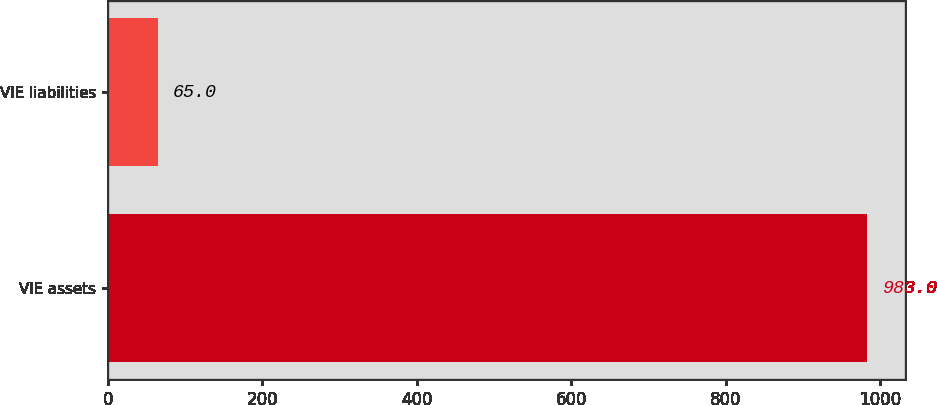Convert chart. <chart><loc_0><loc_0><loc_500><loc_500><bar_chart><fcel>VIE assets<fcel>VIE liabilities<nl><fcel>983<fcel>65<nl></chart> 